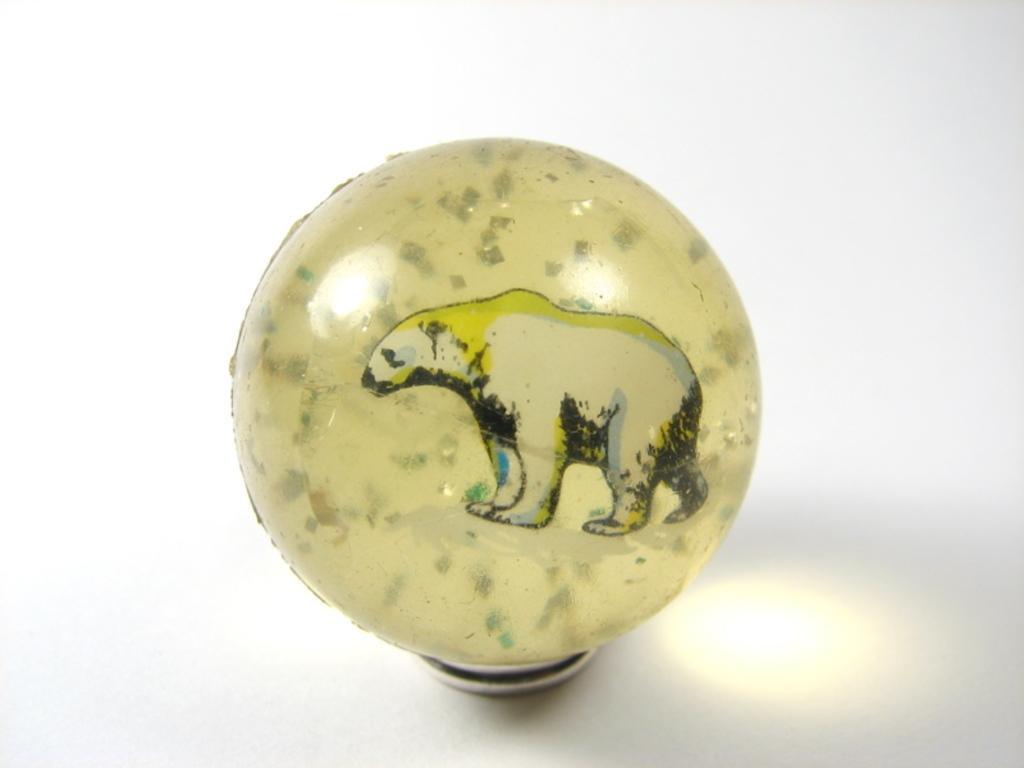Can you describe this image briefly? There is a ball shaped object which has a painting of a bear on it. The background is white. 